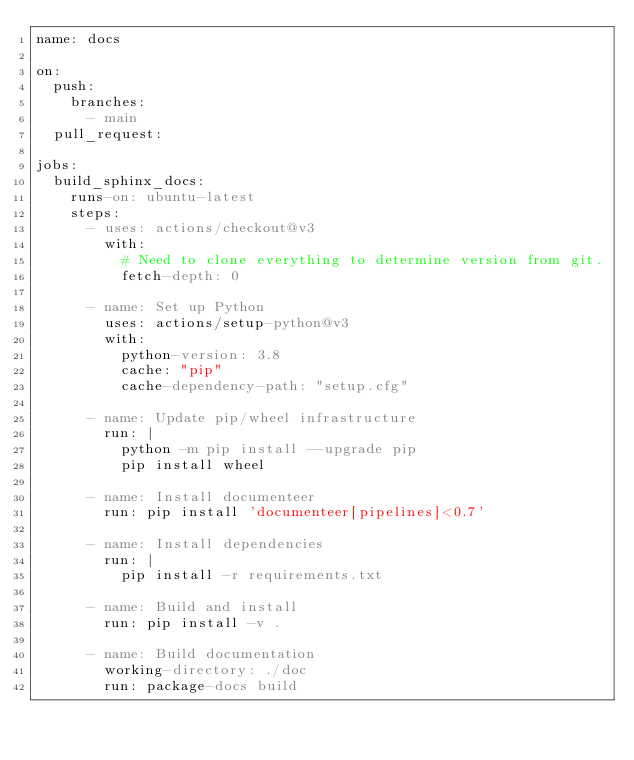Convert code to text. <code><loc_0><loc_0><loc_500><loc_500><_YAML_>name: docs

on:
  push:
    branches:
      - main
  pull_request:

jobs:
  build_sphinx_docs:
    runs-on: ubuntu-latest
    steps:
      - uses: actions/checkout@v3
        with:
          # Need to clone everything to determine version from git.
          fetch-depth: 0

      - name: Set up Python
        uses: actions/setup-python@v3
        with:
          python-version: 3.8
          cache: "pip"
          cache-dependency-path: "setup.cfg"

      - name: Update pip/wheel infrastructure
        run: |
          python -m pip install --upgrade pip
          pip install wheel

      - name: Install documenteer
        run: pip install 'documenteer[pipelines]<0.7'

      - name: Install dependencies
        run: |
          pip install -r requirements.txt

      - name: Build and install
        run: pip install -v .

      - name: Build documentation
        working-directory: ./doc
        run: package-docs build
</code> 